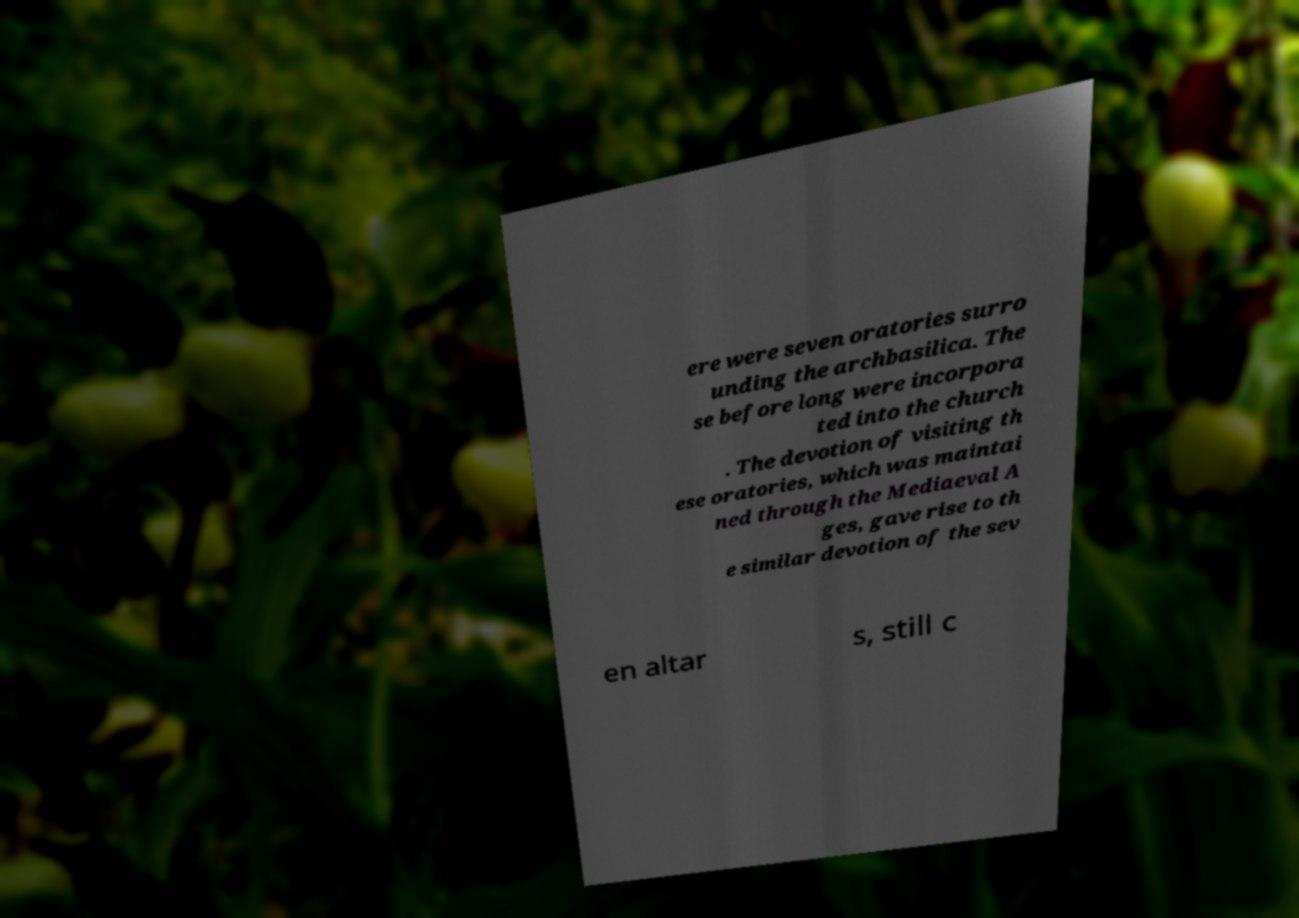Please identify and transcribe the text found in this image. ere were seven oratories surro unding the archbasilica. The se before long were incorpora ted into the church . The devotion of visiting th ese oratories, which was maintai ned through the Mediaeval A ges, gave rise to th e similar devotion of the sev en altar s, still c 